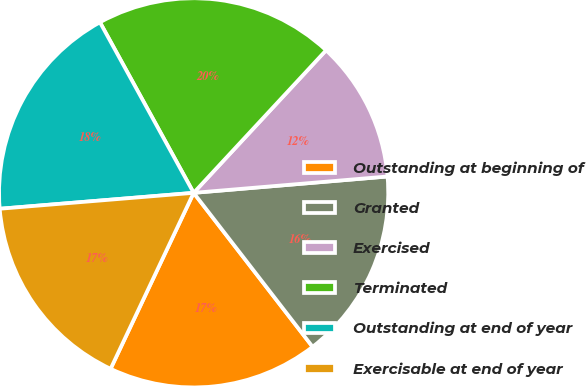<chart> <loc_0><loc_0><loc_500><loc_500><pie_chart><fcel>Outstanding at beginning of<fcel>Granted<fcel>Exercised<fcel>Terminated<fcel>Outstanding at end of year<fcel>Exercisable at end of year<nl><fcel>17.49%<fcel>15.87%<fcel>11.75%<fcel>19.91%<fcel>18.31%<fcel>16.68%<nl></chart> 